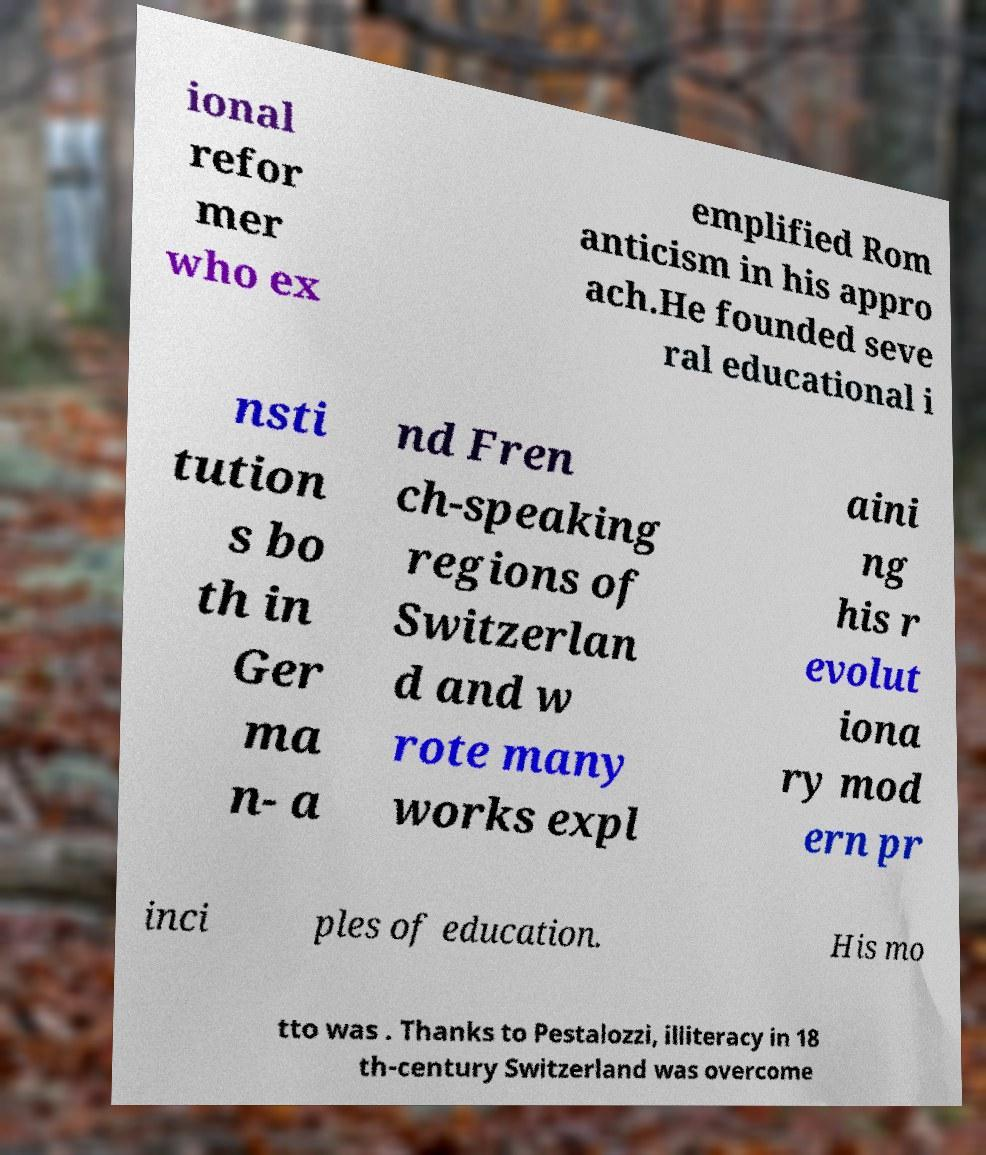There's text embedded in this image that I need extracted. Can you transcribe it verbatim? ional refor mer who ex emplified Rom anticism in his appro ach.He founded seve ral educational i nsti tution s bo th in Ger ma n- a nd Fren ch-speaking regions of Switzerlan d and w rote many works expl aini ng his r evolut iona ry mod ern pr inci ples of education. His mo tto was . Thanks to Pestalozzi, illiteracy in 18 th-century Switzerland was overcome 